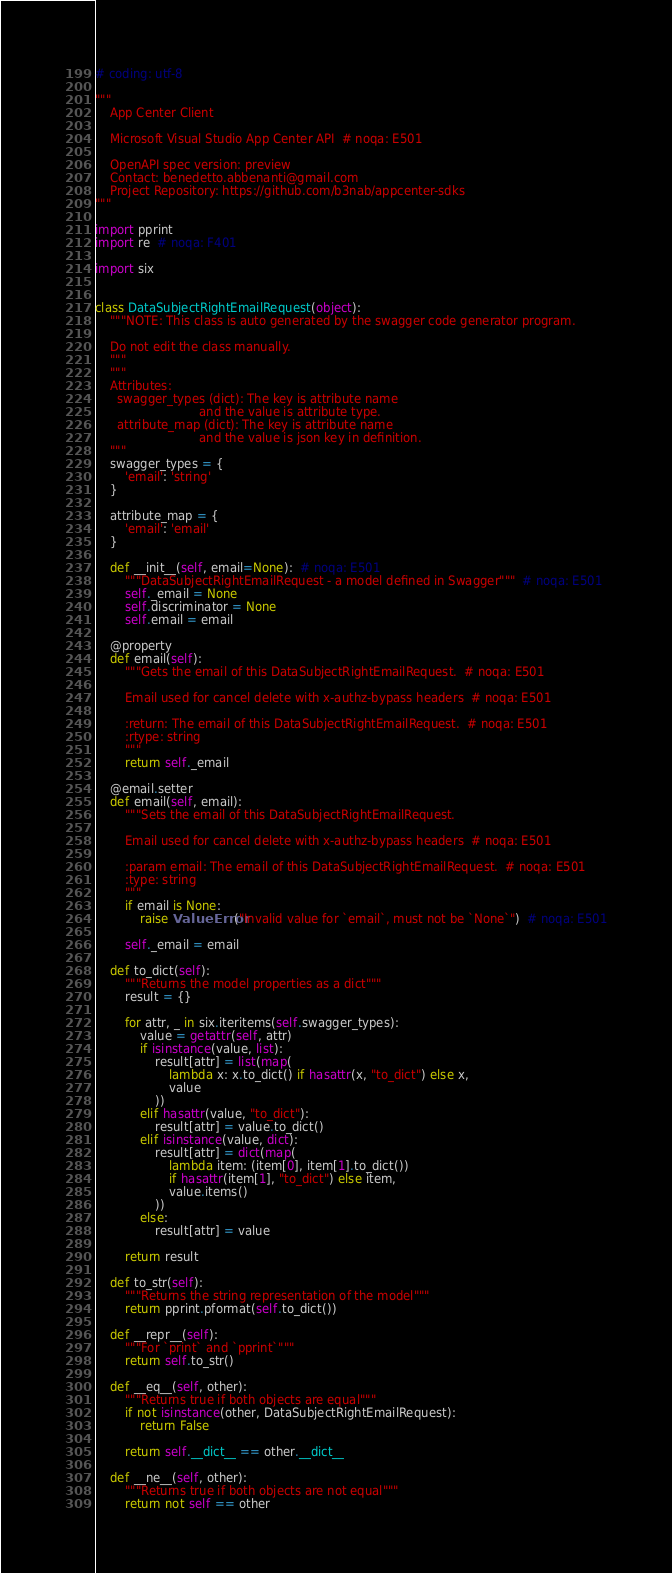<code> <loc_0><loc_0><loc_500><loc_500><_Python_># coding: utf-8

"""
    App Center Client

    Microsoft Visual Studio App Center API  # noqa: E501

    OpenAPI spec version: preview
    Contact: benedetto.abbenanti@gmail.com
    Project Repository: https://github.com/b3nab/appcenter-sdks
"""

import pprint
import re  # noqa: F401

import six


class DataSubjectRightEmailRequest(object):
    """NOTE: This class is auto generated by the swagger code generator program.

    Do not edit the class manually.
    """
    """
    Attributes:
      swagger_types (dict): The key is attribute name
                            and the value is attribute type.
      attribute_map (dict): The key is attribute name
                            and the value is json key in definition.
    """
    swagger_types = {
        'email': 'string'
    }

    attribute_map = {
        'email': 'email'
    }

    def __init__(self, email=None):  # noqa: E501
        """DataSubjectRightEmailRequest - a model defined in Swagger"""  # noqa: E501
        self._email = None
        self.discriminator = None
        self.email = email

    @property
    def email(self):
        """Gets the email of this DataSubjectRightEmailRequest.  # noqa: E501

        Email used for cancel delete with x-authz-bypass headers  # noqa: E501

        :return: The email of this DataSubjectRightEmailRequest.  # noqa: E501
        :rtype: string
        """
        return self._email

    @email.setter
    def email(self, email):
        """Sets the email of this DataSubjectRightEmailRequest.

        Email used for cancel delete with x-authz-bypass headers  # noqa: E501

        :param email: The email of this DataSubjectRightEmailRequest.  # noqa: E501
        :type: string
        """
        if email is None:
            raise ValueError("Invalid value for `email`, must not be `None`")  # noqa: E501

        self._email = email

    def to_dict(self):
        """Returns the model properties as a dict"""
        result = {}

        for attr, _ in six.iteritems(self.swagger_types):
            value = getattr(self, attr)
            if isinstance(value, list):
                result[attr] = list(map(
                    lambda x: x.to_dict() if hasattr(x, "to_dict") else x,
                    value
                ))
            elif hasattr(value, "to_dict"):
                result[attr] = value.to_dict()
            elif isinstance(value, dict):
                result[attr] = dict(map(
                    lambda item: (item[0], item[1].to_dict())
                    if hasattr(item[1], "to_dict") else item,
                    value.items()
                ))
            else:
                result[attr] = value

        return result

    def to_str(self):
        """Returns the string representation of the model"""
        return pprint.pformat(self.to_dict())

    def __repr__(self):
        """For `print` and `pprint`"""
        return self.to_str()

    def __eq__(self, other):
        """Returns true if both objects are equal"""
        if not isinstance(other, DataSubjectRightEmailRequest):
            return False

        return self.__dict__ == other.__dict__

    def __ne__(self, other):
        """Returns true if both objects are not equal"""
        return not self == other
</code> 